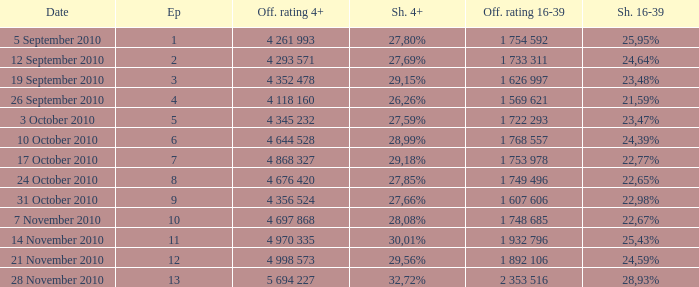What is the official 4+ rating of the episode with a 16-39 share of 24,59%? 4 998 573. 